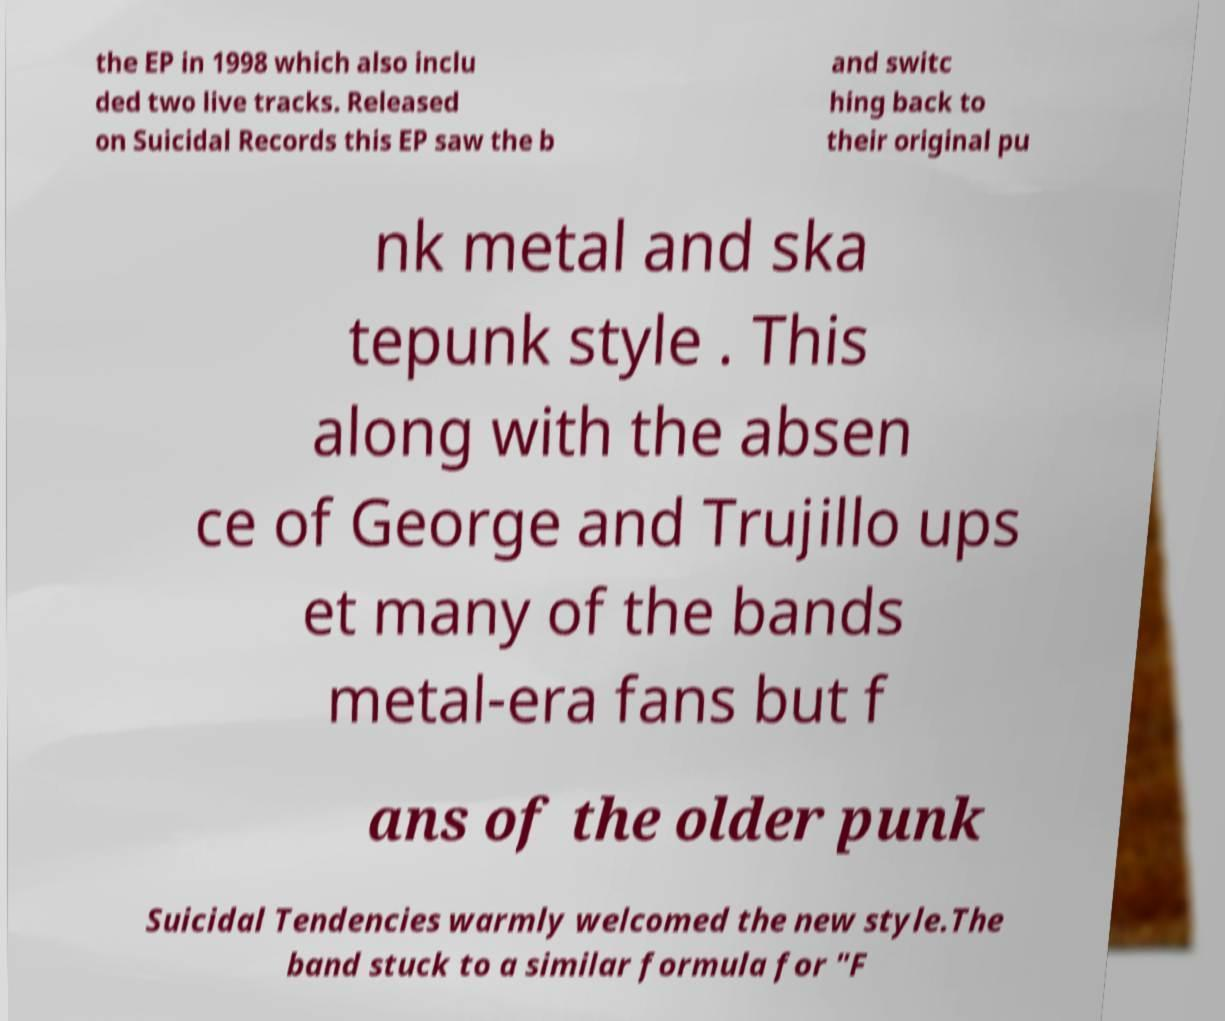For documentation purposes, I need the text within this image transcribed. Could you provide that? the EP in 1998 which also inclu ded two live tracks. Released on Suicidal Records this EP saw the b and switc hing back to their original pu nk metal and ska tepunk style . This along with the absen ce of George and Trujillo ups et many of the bands metal-era fans but f ans of the older punk Suicidal Tendencies warmly welcomed the new style.The band stuck to a similar formula for "F 